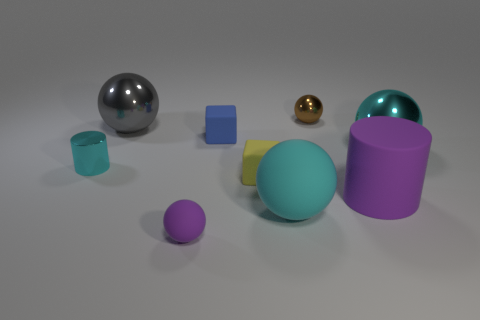What number of tiny spheres are in front of the large cyan ball behind the large purple thing that is on the right side of the brown ball?
Your answer should be very brief. 1. There is a large ball that is on the left side of the cube that is behind the small cyan metal cylinder; what is it made of?
Your answer should be compact. Metal. Is there another small cyan thing that has the same shape as the small cyan thing?
Your answer should be very brief. No. What is the color of the other rubber sphere that is the same size as the brown ball?
Your answer should be compact. Purple. How many things are purple things to the right of the small purple object or shiny objects that are on the right side of the large rubber cylinder?
Keep it short and to the point. 2. How many objects are metallic spheres or small blue objects?
Your response must be concise. 4. What size is the sphere that is in front of the brown metallic thing and behind the large cyan metallic thing?
Make the answer very short. Large. How many small blue cubes are made of the same material as the tiny cylinder?
Your answer should be very brief. 0. What is the color of the other big object that is the same material as the gray object?
Offer a very short reply. Cyan. Do the small metal object that is in front of the tiny brown metal thing and the tiny matte sphere have the same color?
Ensure brevity in your answer.  No. 